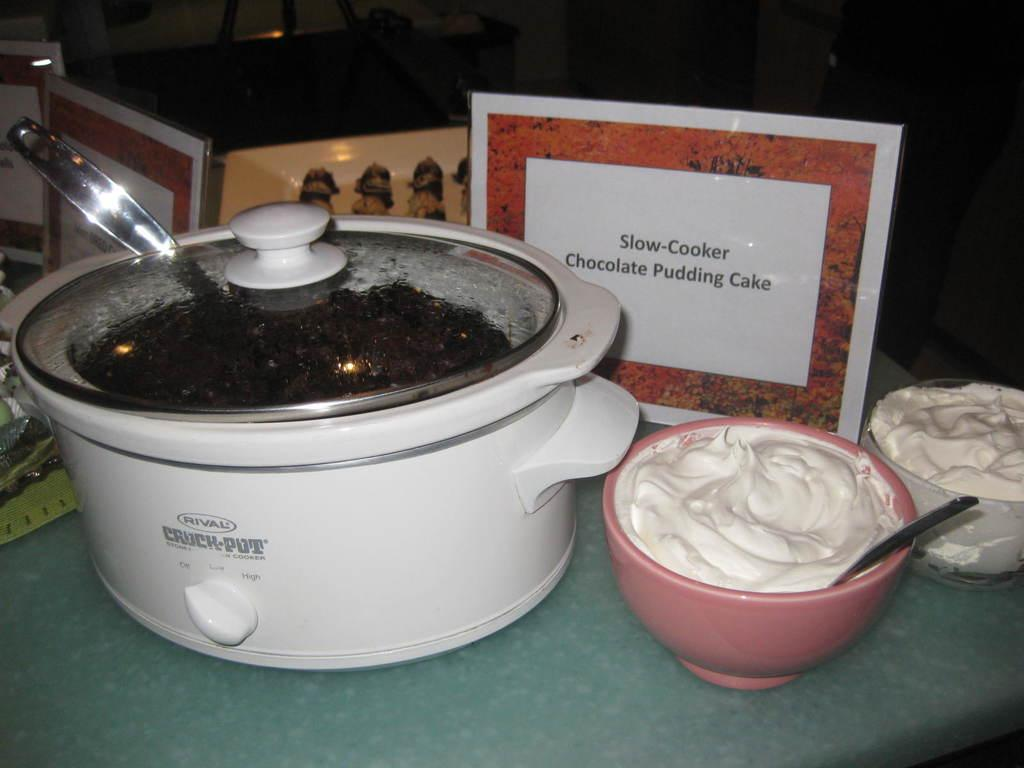Provide a one-sentence caption for the provided image. A crockpot full of slow-cooker chocolate pudding cake with a bowl of whip cream sitting next to it. 